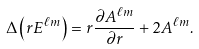Convert formula to latex. <formula><loc_0><loc_0><loc_500><loc_500>\Delta \left ( r E ^ { \ell m } \right ) = r \frac { \partial A ^ { \ell m } } { \partial r } + 2 A ^ { \ell m } .</formula> 